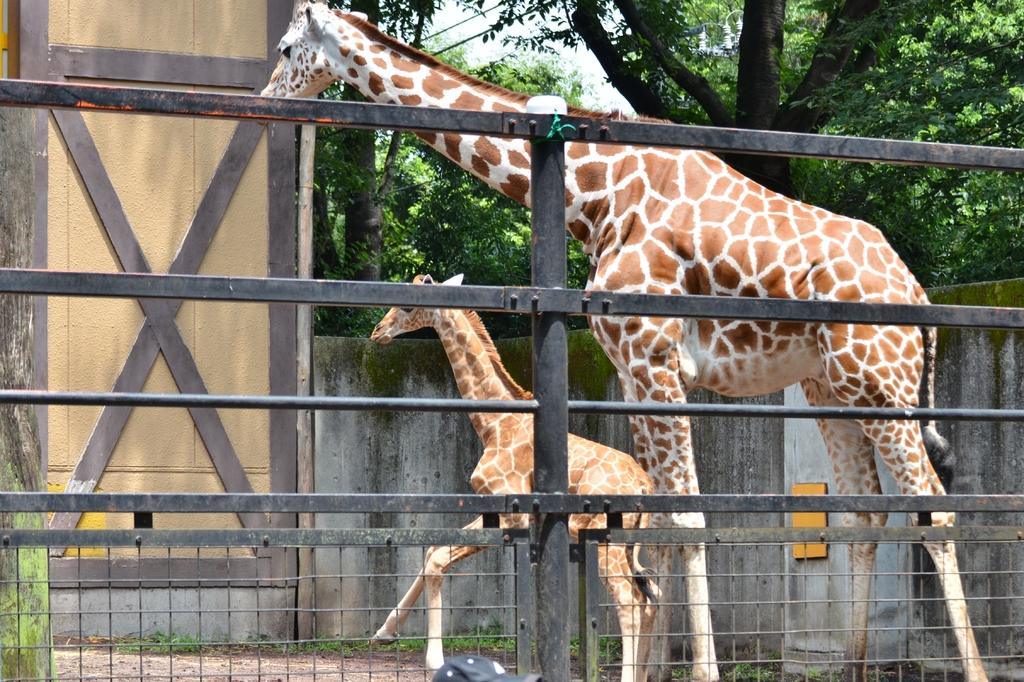How many giraffes are in the image? There are two giraffes in the image. What is separating the giraffes from the background? There is a fence in the image. What type of vegetation can be seen in the background? There is grass visible in the background of the image. What other structures are visible in the background? There is a wall in the background of the image. What else can be seen in the sky in the background? There are trees in the background of the image. What is visible above the trees and wall? The sky is visible in the background of the image. What type of committee is responsible for the copper production in the image? There is no mention of a committee or copper production in the image; it features two giraffes, a fence, and a background with grass, a wall, trees, and the sky. 